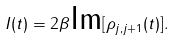Convert formula to latex. <formula><loc_0><loc_0><loc_500><loc_500>I ( t ) = 2 \beta \text {Im} [ \rho _ { j , j + 1 } ( t ) ] .</formula> 